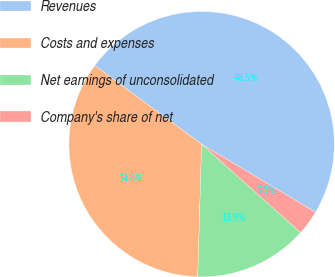Convert chart to OTSL. <chart><loc_0><loc_0><loc_500><loc_500><pie_chart><fcel>Revenues<fcel>Costs and expenses<fcel>Net earnings of unconsolidated<fcel>Company's share of net<nl><fcel>48.49%<fcel>34.63%<fcel>13.86%<fcel>3.02%<nl></chart> 